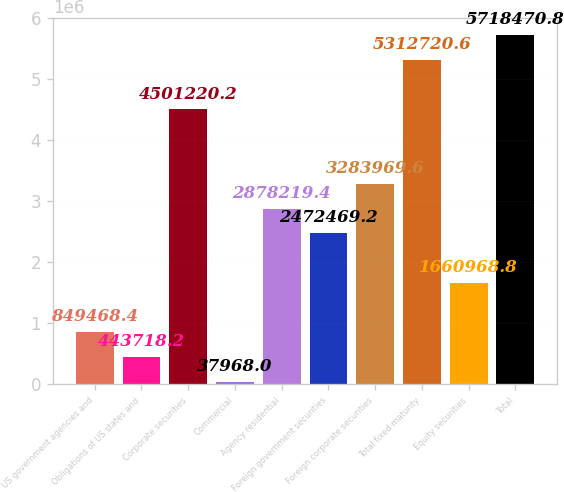Convert chart to OTSL. <chart><loc_0><loc_0><loc_500><loc_500><bar_chart><fcel>US government agencies and<fcel>Obligations of US states and<fcel>Corporate securities<fcel>Commercial<fcel>Agency residential<fcel>Foreign government securities<fcel>Foreign corporate securities<fcel>Total fixed maturity<fcel>Equity securities<fcel>Total<nl><fcel>849468<fcel>443718<fcel>4.50122e+06<fcel>37968<fcel>2.87822e+06<fcel>2.47247e+06<fcel>3.28397e+06<fcel>5.31272e+06<fcel>1.66097e+06<fcel>5.71847e+06<nl></chart> 